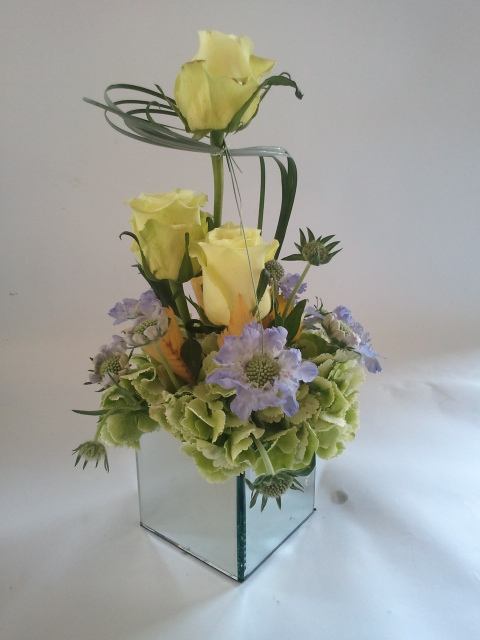<image>Are these flowers made of plastic? I am not sure if the flowers are made of plastic. It could be either yes or no. Are these flowers made of plastic? I am not sure if these flowers are made of plastic. It can be both yes or no. 